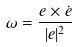<formula> <loc_0><loc_0><loc_500><loc_500>\omega = \frac { e \times \dot { e } } { | e | ^ { 2 } }</formula> 